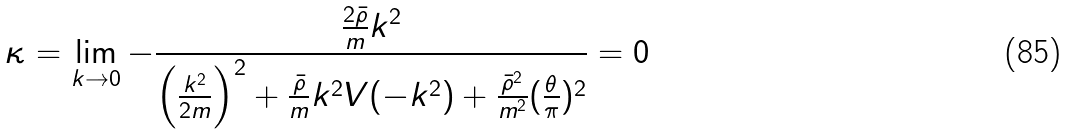Convert formula to latex. <formula><loc_0><loc_0><loc_500><loc_500>\kappa = \lim _ { { k } \rightarrow 0 } - \frac { \frac { 2 \bar { \rho } } { m } { k } ^ { 2 } } { \left ( \frac { { k } ^ { 2 } } { 2 m } \right ) ^ { 2 } + \frac { \bar { \rho } } { m } { k } ^ { 2 } V ( - { k } ^ { 2 } ) + \frac { \bar { \rho } ^ { 2 } } { m ^ { 2 } } ( \frac { \theta } { \pi } ) ^ { 2 } } = 0</formula> 